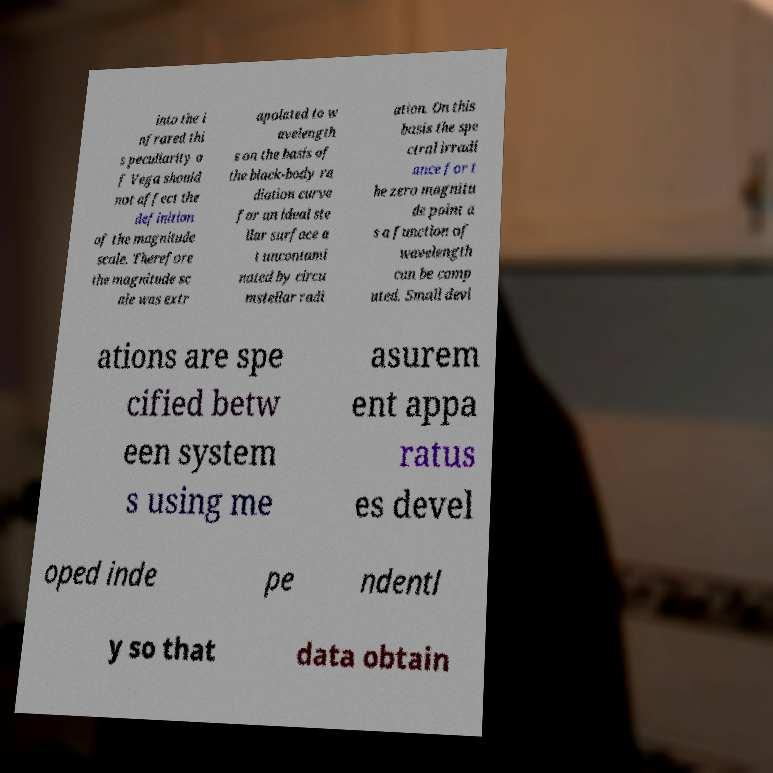There's text embedded in this image that I need extracted. Can you transcribe it verbatim? into the i nfrared thi s peculiarity o f Vega should not affect the definition of the magnitude scale. Therefore the magnitude sc ale was extr apolated to w avelength s on the basis of the black-body ra diation curve for an ideal ste llar surface a t uncontami nated by circu mstellar radi ation. On this basis the spe ctral irradi ance for t he zero magnitu de point a s a function of wavelength can be comp uted. Small devi ations are spe cified betw een system s using me asurem ent appa ratus es devel oped inde pe ndentl y so that data obtain 